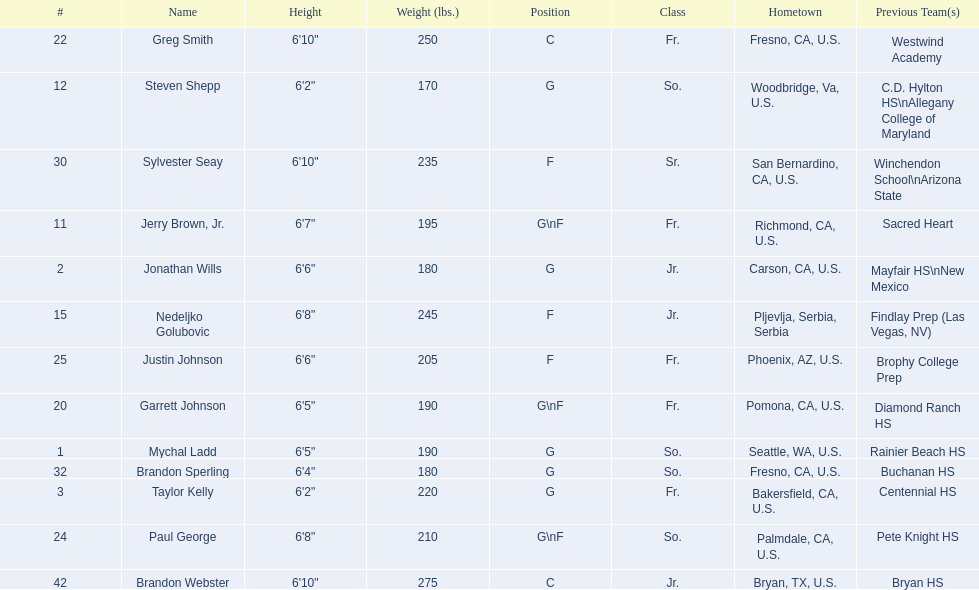Who are the players for the 2009-10 fresno state bulldogs men's basketball team? Mychal Ladd, Jonathan Wills, Taylor Kelly, Jerry Brown, Jr., Steven Shepp, Nedeljko Golubovic, Garrett Johnson, Greg Smith, Paul George, Justin Johnson, Sylvester Seay, Brandon Sperling, Brandon Webster. What are their heights? 6'5", 6'6", 6'2", 6'7", 6'2", 6'8", 6'5", 6'10", 6'8", 6'6", 6'10", 6'4", 6'10". What is the shortest height? 6'2", 6'2". What is the lowest weight? 6'2". Which player is it? Steven Shepp. 